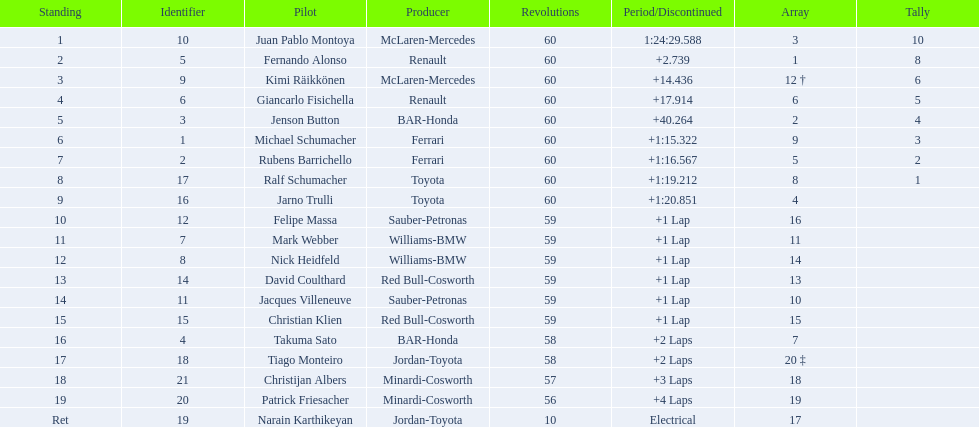After 8th position, how many points does a driver receive? 0. 